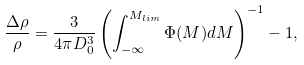<formula> <loc_0><loc_0><loc_500><loc_500>\frac { \Delta \rho } { \rho } = \frac { 3 } { 4 \pi D _ { 0 } ^ { 3 } } \left ( \int ^ { M _ { l i m } } _ { - \infty } \Phi ( M ) d M \right ) ^ { - 1 } - 1 ,</formula> 